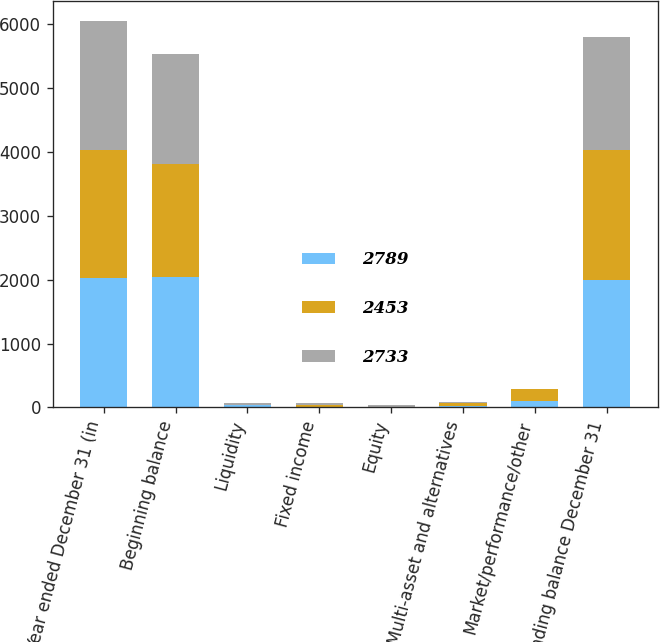<chart> <loc_0><loc_0><loc_500><loc_500><stacked_bar_chart><ecel><fcel>Year ended December 31 (in<fcel>Beginning balance<fcel>Liquidity<fcel>Fixed income<fcel>Equity<fcel>Multi-asset and alternatives<fcel>Market/performance/other<fcel>Ending balance December 31<nl><fcel>2789<fcel>2018<fcel>2034<fcel>31<fcel>1<fcel>2<fcel>24<fcel>103<fcel>1987<nl><fcel>2453<fcel>2017<fcel>1771<fcel>9<fcel>36<fcel>11<fcel>43<fcel>186<fcel>2034<nl><fcel>2733<fcel>2016<fcel>1723<fcel>24<fcel>30<fcel>29<fcel>22<fcel>1<fcel>1771<nl></chart> 